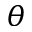Convert formula to latex. <formula><loc_0><loc_0><loc_500><loc_500>\theta</formula> 